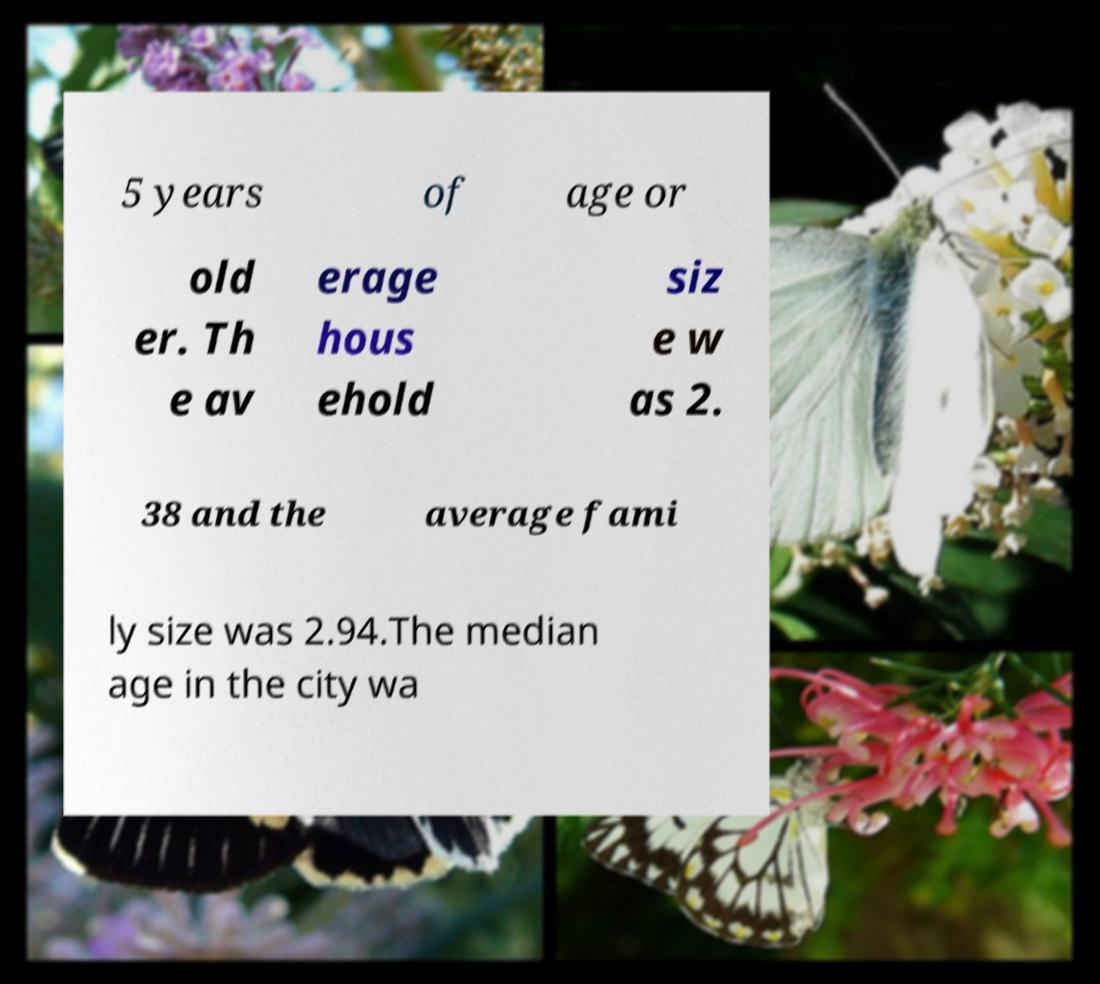What messages or text are displayed in this image? I need them in a readable, typed format. 5 years of age or old er. Th e av erage hous ehold siz e w as 2. 38 and the average fami ly size was 2.94.The median age in the city wa 